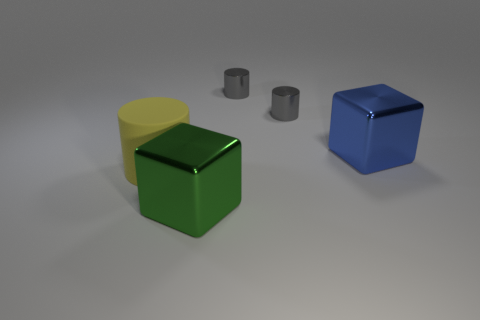Subtract all large yellow cylinders. How many cylinders are left? 2 Subtract 1 cylinders. How many cylinders are left? 2 Add 4 blue metallic objects. How many objects exist? 9 Subtract all cylinders. How many objects are left? 2 Subtract all large cubes. Subtract all big shiny cubes. How many objects are left? 1 Add 2 green shiny cubes. How many green shiny cubes are left? 3 Add 5 large yellow cylinders. How many large yellow cylinders exist? 6 Subtract 1 yellow cylinders. How many objects are left? 4 